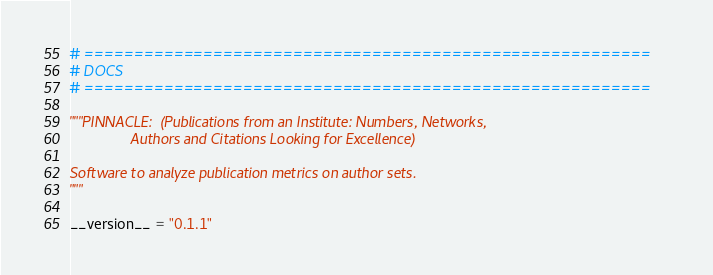Convert code to text. <code><loc_0><loc_0><loc_500><loc_500><_Python_># =========================================================
# DOCS
# =========================================================

"""PINNACLE:  (Publications from an Institute: Numbers, Networks,
               Authors and Citations Looking for Excellence)

Software to analyze publication metrics on author sets.
"""

__version__ = "0.1.1"
</code> 